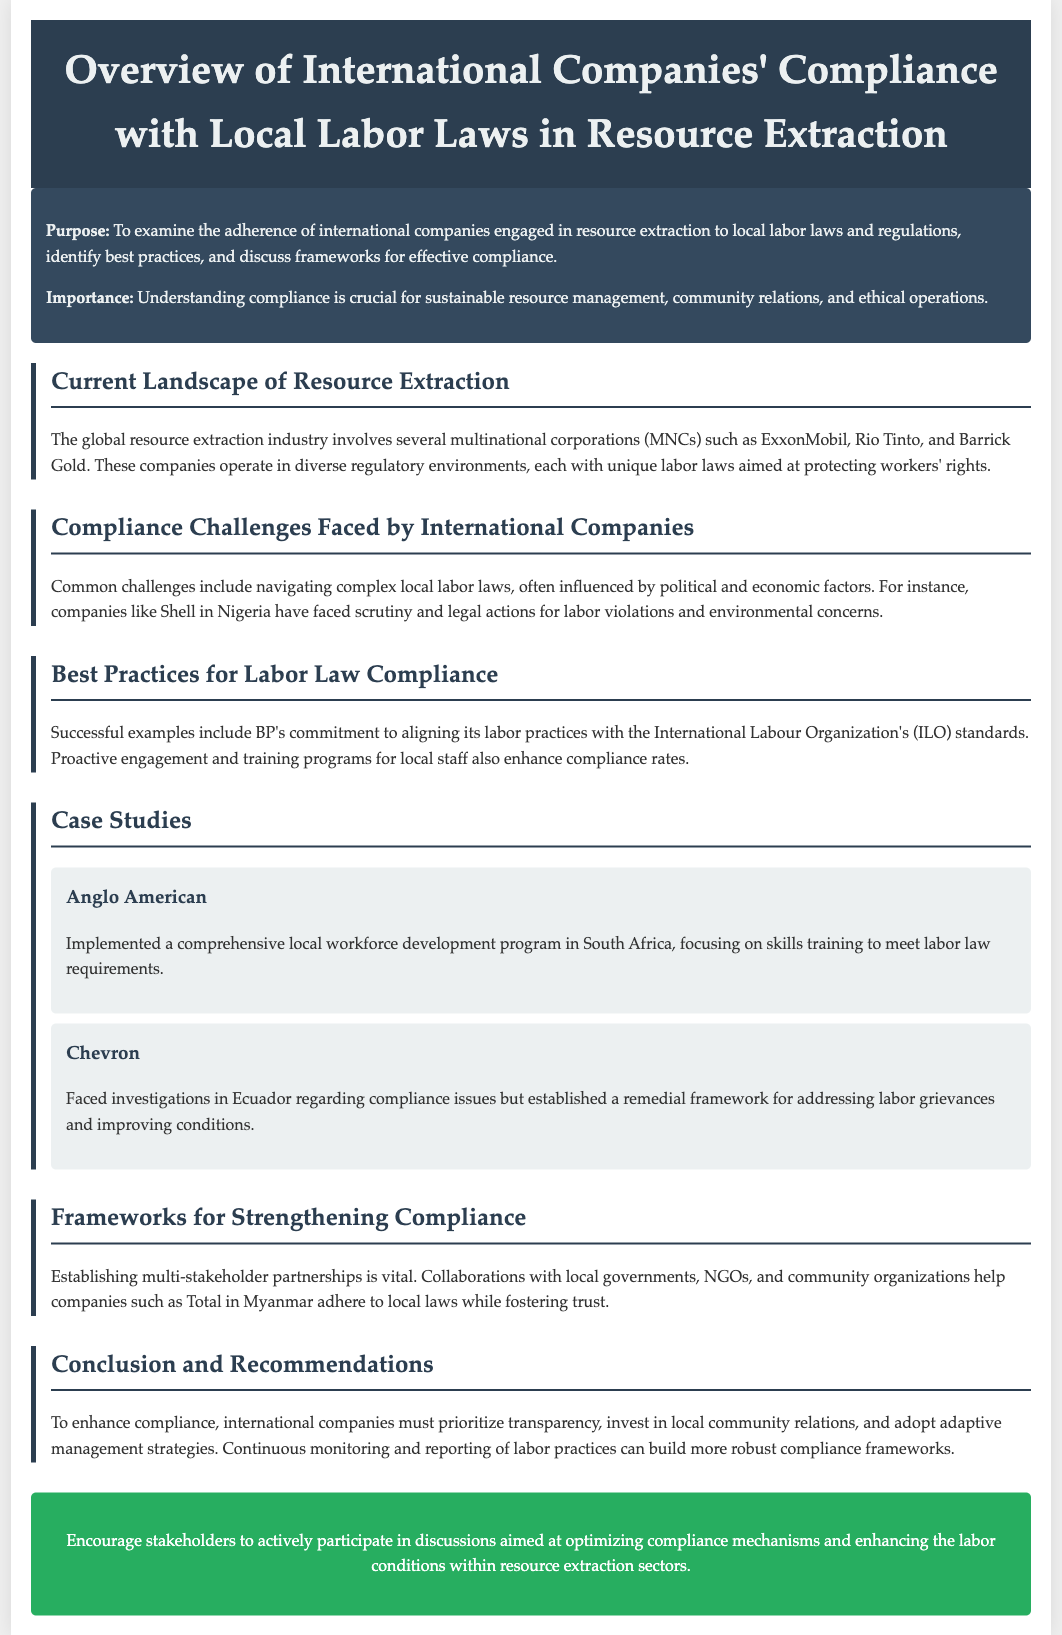What is the title of the document? The title appears at the top of the document and describes the main focus on compliance with labor laws.
Answer: Overview of International Companies' Compliance with Local Labor Laws in Resource Extraction What company faced scrutiny in Nigeria? The document mentions a specific company that faced scrutiny and legal actions for labor violations in Nigeria.
Answer: Shell Which organization's standards does BP align its labor practices with? The document states that BP's commitment to compliance is linked to a specific international organization influencing labor practices.
Answer: International Labour Organization What did Anglo American implement in South Africa? The document provides information about a program that Anglo American has established to enhance its workforce development.
Answer: A comprehensive local workforce development program What is a key recommendation for enhancing compliance? The document discusses suggestions for international companies to improve their adherence to local labor laws, highlighting a specific approach.
Answer: Transparency What type of partnerships are vital for strengthening compliance? The document indicates the importance of certain collaborations in achieving better compliance with local labor laws.
Answer: Multi-stakeholder partnerships How many case studies are mentioned in the document? The document lists a specific number of case studies related to companies' compliance efforts.
Answer: Two What is the call to action in the document? The last section of the document emphasizes the importance of a certain activity regarding compliance mechanisms in resource extraction.
Answer: Encourage stakeholders to actively participate in discussions 